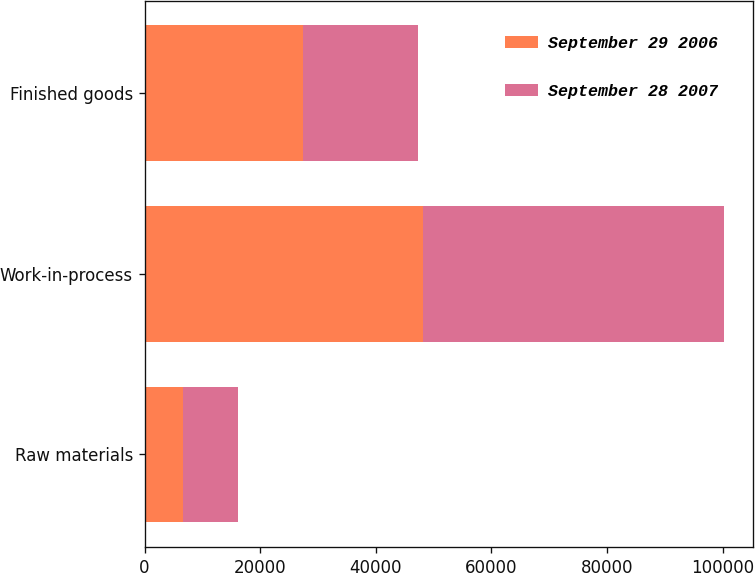<chart> <loc_0><loc_0><loc_500><loc_500><stacked_bar_chart><ecel><fcel>Raw materials<fcel>Work-in-process<fcel>Finished goods<nl><fcel>September 29 2006<fcel>6624<fcel>48128<fcel>27357<nl><fcel>September 28 2007<fcel>9476<fcel>52097<fcel>19956<nl></chart> 